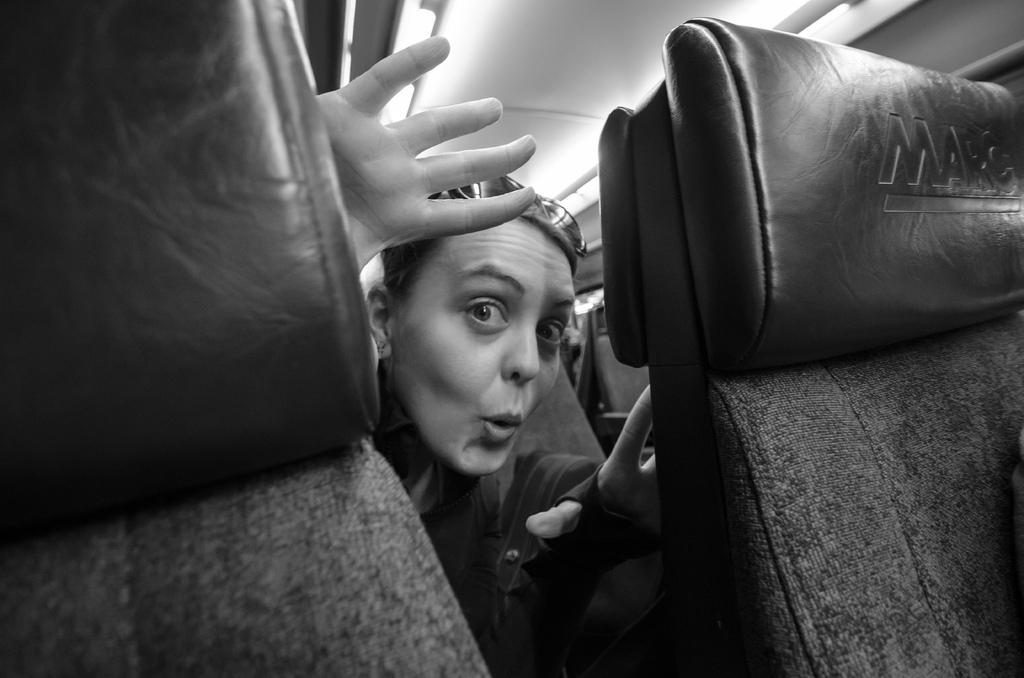What is the person in the image doing? The person is in a vehicle. How many seats are visible in front of the person? There are two seats visible in front of the person. How many dolls are sitting next to the person in the vehicle? There are no dolls present in the image. What type of train is visible in the background of the image? There is no train visible in the image; it only shows a person in a vehicle with two seats in front of them. 